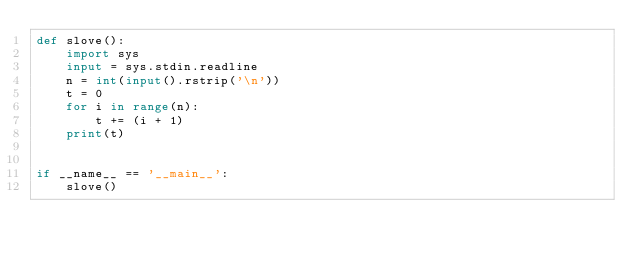Convert code to text. <code><loc_0><loc_0><loc_500><loc_500><_Python_>def slove():
    import sys
    input = sys.stdin.readline
    n = int(input().rstrip('\n'))
    t = 0
    for i in range(n):
        t += (i + 1)
    print(t)


if __name__ == '__main__':
    slove()
</code> 